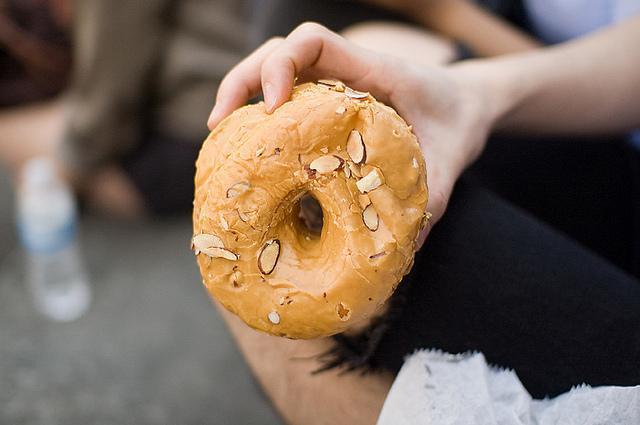How many people can be seen?
Give a very brief answer. 2. How many rolls of toilet paper are on the toilet?
Give a very brief answer. 0. 